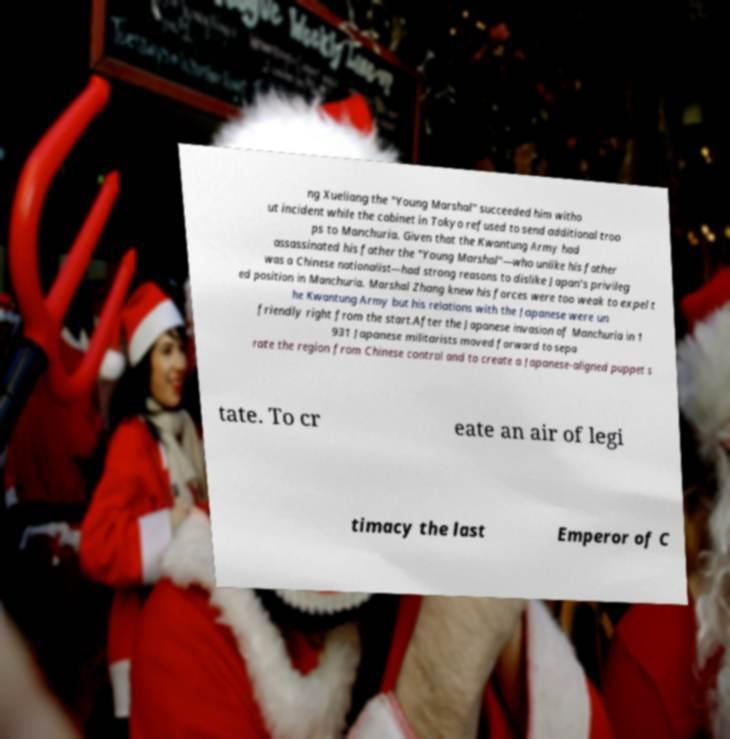Can you read and provide the text displayed in the image?This photo seems to have some interesting text. Can you extract and type it out for me? ng Xueliang the "Young Marshal" succeeded him witho ut incident while the cabinet in Tokyo refused to send additional troo ps to Manchuria. Given that the Kwantung Army had assassinated his father the "Young Marshal"—who unlike his father was a Chinese nationalist—had strong reasons to dislike Japan's privileg ed position in Manchuria. Marshal Zhang knew his forces were too weak to expel t he Kwantung Army but his relations with the Japanese were un friendly right from the start.After the Japanese invasion of Manchuria in 1 931 Japanese militarists moved forward to sepa rate the region from Chinese control and to create a Japanese-aligned puppet s tate. To cr eate an air of legi timacy the last Emperor of C 